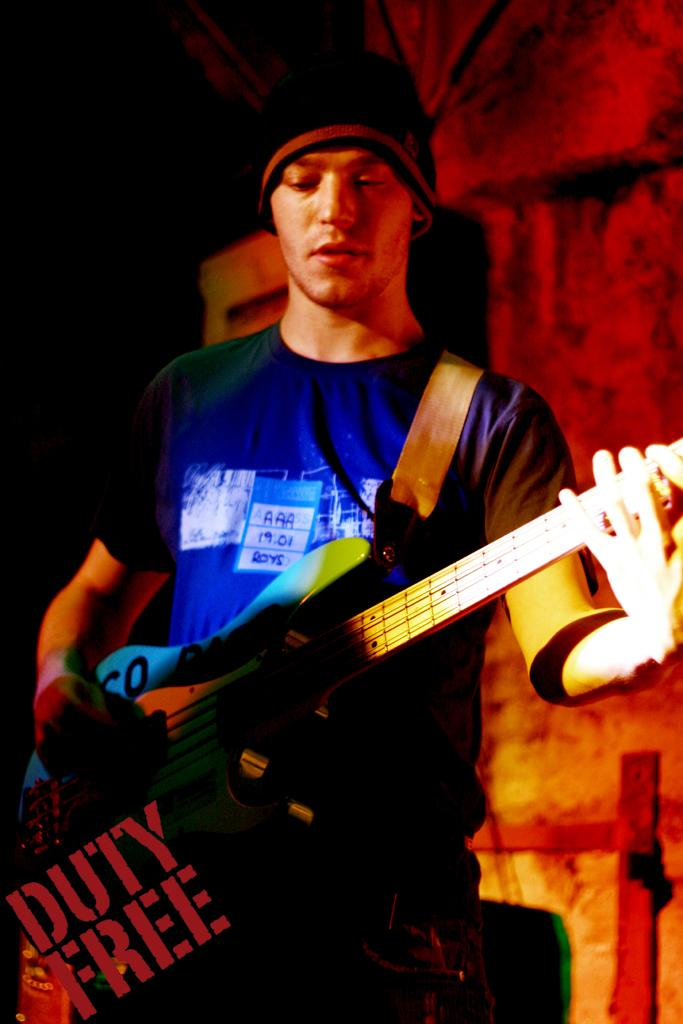Who is the main subject in the image? There is a man in the image. What is the man wearing? The man is wearing a blue t-shirt. What is the man doing in the image? The man is playing a guitar. What type of loaf is the man holding in the image? There is no loaf present in the image; the man is playing a guitar. What type of pleasure does the man experience while playing the guitar in the image? The image does not provide information about the man's emotions or experiences while playing the guitar. 